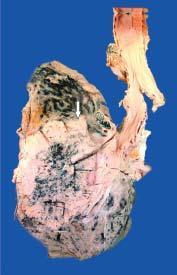what shows grey-white fleshy tumour in the bronchus at its bifurcation?
Answer the question using a single word or phrase. Sectioned surface 